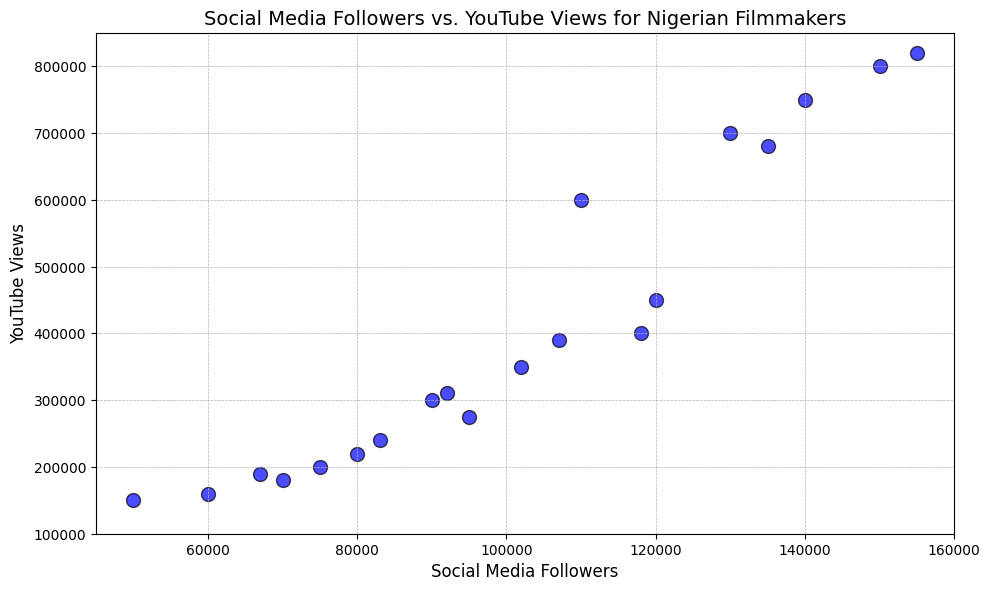What is the general trend between social media followers and YouTube views? By observing the scatter plot, one can see that as the number of social media followers increases, the number of YouTube views also tends to increase. This indicates a positive correlation between social media followers and YouTube views.
Answer: Positive correlation Which filmmaker has the most social media followers, and how many YouTube views do they have? The filmmaker with the most social media followers is Filmmaker17 with 155,000 followers. They have 820,000 YouTube views.
Answer: Filmmaker17, 820,000 views Identify the filmmakers who have more than 100,000 social media followers but less than 400,000 YouTube views. By examining the scatter plot, the filmmakers falling in this range are Filmmaker6 (95,000 followers, 275,000 views), Filmmaker18 (102,000 followers, 350,000 views), Filmmaker19 (118,000 followers, 400,000 views), and Filmmaker20 (107,000 followers, 390,000 views). Note that some may lie on the boundary and careful visual confirmation is needed.
Answer: Filmmaker18, Filmmaker19, Filmmaker20 Which point represents Filmmaker11, and what are their respective followers and views? Filmmaker11 is located at the highest followers along with another point but the highest views, representing 150,000 social media followers and 800,000 YouTube views. Final confirmation on exact positions based on the dataset: Filmmaker17 vs Filmmaker11.
Answer: 150,000 followers, 800,000 views What is the difference in YouTube views between the filmmakers with the least and most social media followers? Filmmaker1 has the least social media followers (50,000) and Filmmaker17 has the most (155,000). Filmmaker1 has 150,000 YouTube views, whereas Filmmaker17 has 820,000 views. Therefore, the difference is 820,000 - 150,000 = 670,000 views.
Answer: 670,000 views Which filmmaker falls closest to the average followers and what are their corresponding views? To find the average followers: (sum of all followers) / (number of filmmakers) = (sum(50000, 75000, 120000, ...)) / 20 = 101,400. Filmmaker9 with 80,000 followers is closest visually against the average, and they have 220,000 views. Confirmation needed due to close-in values visually.
Answer: Filmmaker9, 220,000 views 